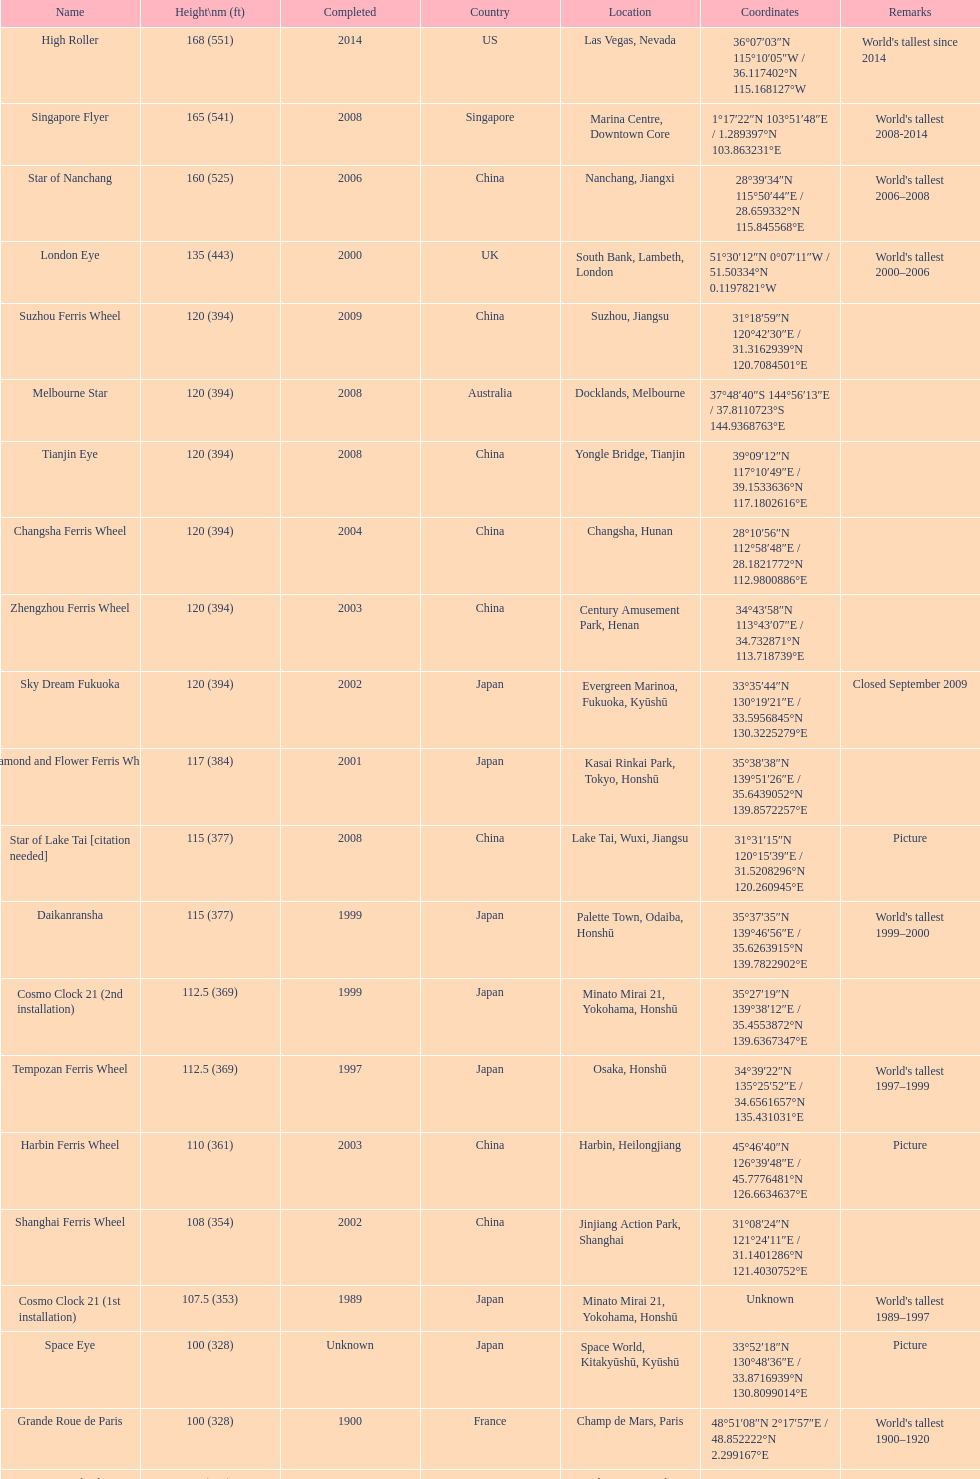Which of these roller coasters has the earliest origin: star of lake tai, star of nanchang, melbourne star? Star of Nanchang. 